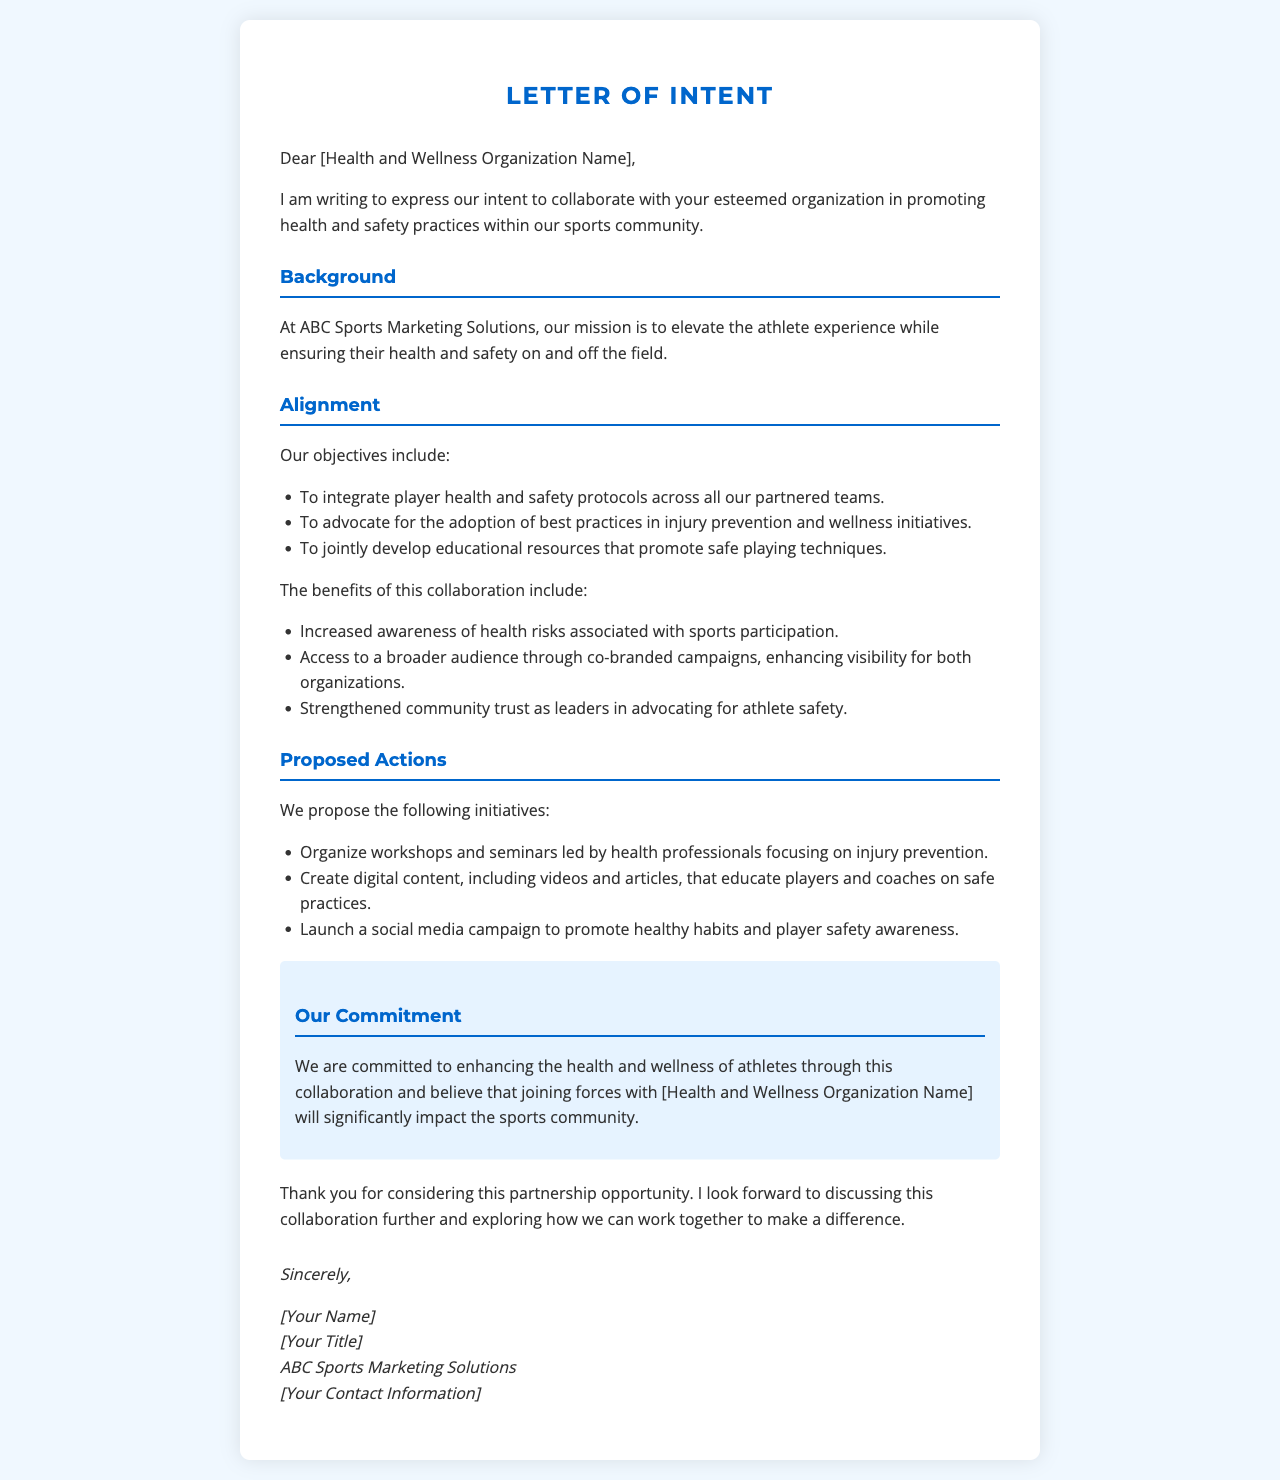What is the name of the organization sending the letter? The name of the organization sending the letter is mentioned in the document as ABC Sports Marketing Solutions.
Answer: ABC Sports Marketing Solutions Who is the intended recipient of the letter? The letter is addressed to a specific recipient, indicated by [Health and Wellness Organization Name].
Answer: [Health and Wellness Organization Name] What is one objective mentioned in the letter? One of the objectives stated in the letter is to integrate player health and safety protocols across all partnered teams.
Answer: Integrate player health and safety protocols List one proposed initiative from the letter. The letter lists various initiatives; one of them is to organize workshops and seminars led by health professionals.
Answer: Organize workshops and seminars What color is used for the headings in the letter? The color used for the headings in the letter is a shade of blue specified in the styles.
Answer: #0066cc What is the tone of the collaboration being proposed in the letter? The tone expressed throughout the letter is one of commitment and partnership to enhance health and wellness.
Answer: Commitment Which specific area does the letter aim to create educational resources in? The letter aims to create educational resources focused on safe playing techniques.
Answer: Safe playing techniques What does the author appreciate regarding the partnership opportunity? The author expresses gratitude for considering the partnership opportunity.
Answer: Considering this partnership opportunity What type of content is proposed to be created for education? The letter mentions creating digital content, including videos and articles, for player education.
Answer: Digital content, including videos and articles 